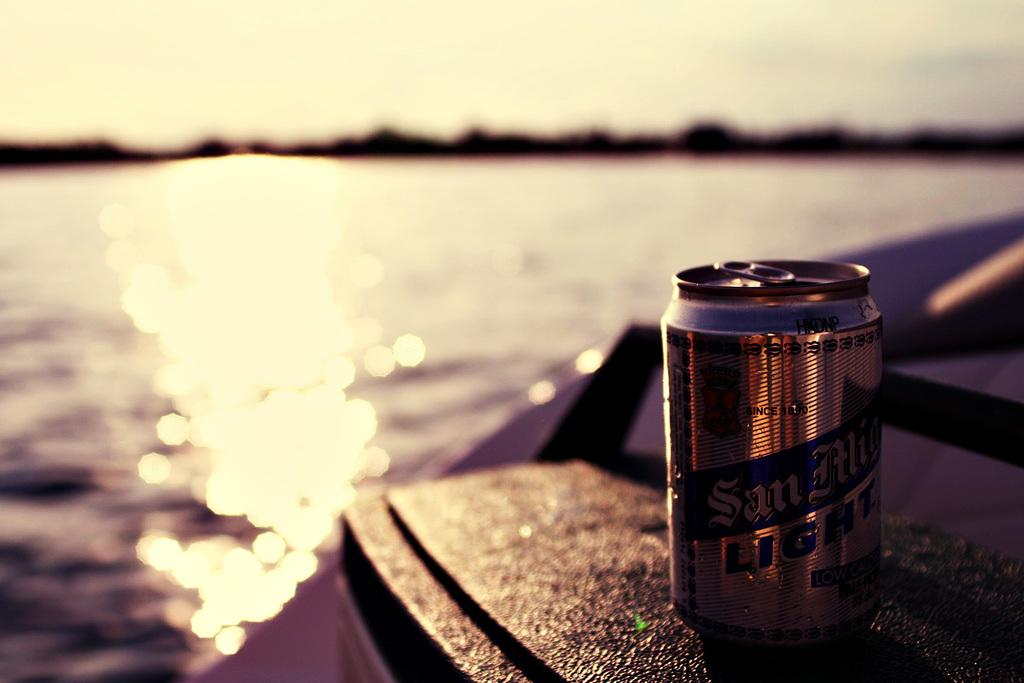<image>
Create a compact narrative representing the image presented. A San Alicia Light beer can being shone on by the setting sun overlooking a lake. 